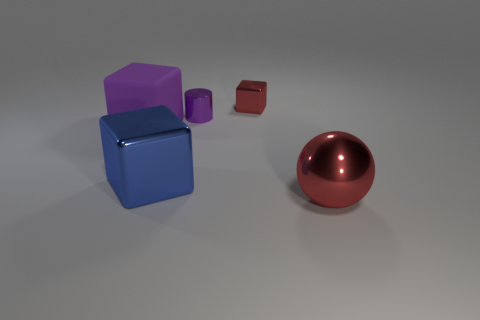Add 5 large metal cubes. How many objects exist? 10 Subtract all cylinders. How many objects are left? 4 Add 4 cylinders. How many cylinders are left? 5 Add 5 large red metal cylinders. How many large red metal cylinders exist? 5 Subtract 0 purple spheres. How many objects are left? 5 Subtract all blue rubber objects. Subtract all purple objects. How many objects are left? 3 